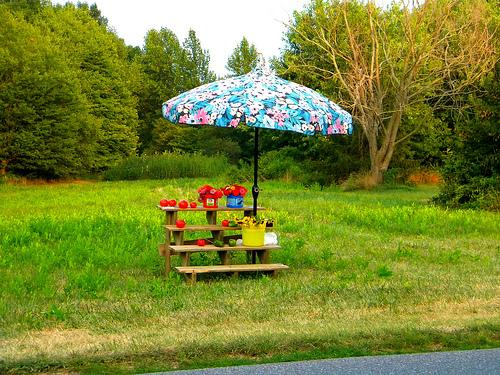Describe the setting of the image. The setting is a grassy field with a wooden stand, an umbrella, flowers in buckets, and street next to it. In which part of the image can a street be seen and how large is it? The street can be seen in front of the grass, with a width of 173 and a height of 173. Which items can be found on the vegetable stand? Four red apples, tomatoes, and three green peppers can be found on the vegetable stand. What are the colors of the containers holding red flowers? The colors of the containers holding red flowers are red and blue. What objects can be found on the wooden steps? There are flowers, fruit, a red container with red flowers, and some red apples on the wooden steps. Are there any other objects under the umbrella besides the stand, and if so, what are they? No, there are no other objects under the umbrella besides the stand. What type of tree is present in the field? There is a bare tree with no leaves in the field. What is the primary sentiment or emotion that can be associated with this image? The primary sentiment could be a sense of relaxation or peacefulness in a natural environment. Count the number of umbrellas and describe their features. There is one umbrella, which can be described as a flower patio umbrella. Identify the type of plants in the yellow bucket. There are sunflowers in the yellow bucket. List all the objects present in the image. Vegetable stand, grass, bucket of flowers, umbrella, pole, tomatoes, street, cucumbers, brown patch of grass, bare tree, wooden steps, tree, road, red container of flowers, blue container of flowers, sunflowers, apples, peppers. State the color and type of flowers in the yellow bucket. Yellow sunflowers can be found in the yellow bucket. Determine if there are any anomalies in the image. There are no significant anomalies in the image. Do you notice a person holding a bucket of flowers near the umbrella? There is a bucket of flowers, but no mention of a person holding it. Rate the quality of the image on a scale of 1 to 10. 7 What type of setting does the small stand and umbrella create? The small stand and umbrella create a park-like setting. Identify any possible interactions between objects in the image. The vegetable stand and umbrella provide shade for the products being sold. What are the characteristics of the umbrella on the pole? The umbrella is open, has a flower design, and is on a pole supporting it. What type of vegetable can be found at the vegetable stand? There are tomatoes and cucumbers on the stand. Is there a basket filled with only red flowers on the far right side of the image? There is a red flower, but it's not in a basket or in a specified position in the image. What is the primary function of the umbrella in the image? The primary function of the umbrella is to provide shade. Describe the overall sentiment of the image. The image has a peaceful and calm sentiment. Count the number of green peppers in the image. There are three green peppers. Is there a bunny hopping across the green grass? There is green grass in the image, but no mention of a bunny or any other animals. Identify the fruit found on the vegetable stand. Four red apples are found on the vegetable stand. Identify the object referred to as "the pole of the umbrella." The object is the narrow vertical structure located at X:250 Y:127 with Width:12 Height:12. Can you spot any purple cucumbers on the wooden stand? Cucumbers are present in the image, but they are not specified as purple. Can you see a blue fence surrounding the field? There is a field in the image, but no mention of a fence or any specific color. Choose the most accurate description of the steps in the image. B) Wood steps with flowers and fruit Do you see a yellow umbrella in the middle of the field? The umbrella is present, but it is not specified as yellow. Are there any textual elements present in the image? No, there are no textual elements in the image. Which objects can be found in the grassy area? Vegetable stand, wooden steps, flower buckets, umbrella, pole, and brown patch of grass can be found in the grassy area. Is there a tree with leaves in the image? No, there is only a bare tree with no leaves on it. Identify the color of the containers holding red flowers. The containers holding red flowers are blue and red. Where is the street located in relation to the field? The street is next to the field. 